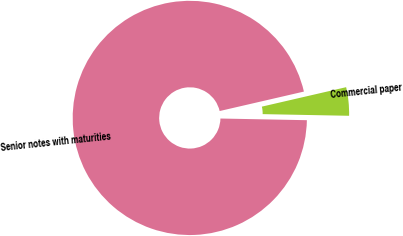Convert chart. <chart><loc_0><loc_0><loc_500><loc_500><pie_chart><fcel>Commercial paper<fcel>Senior notes with maturities<nl><fcel>3.92%<fcel>96.08%<nl></chart> 